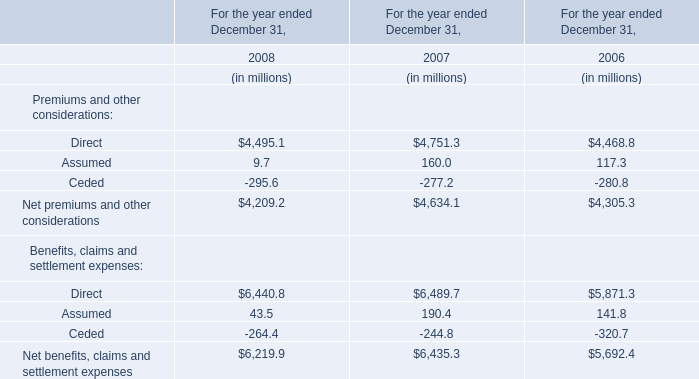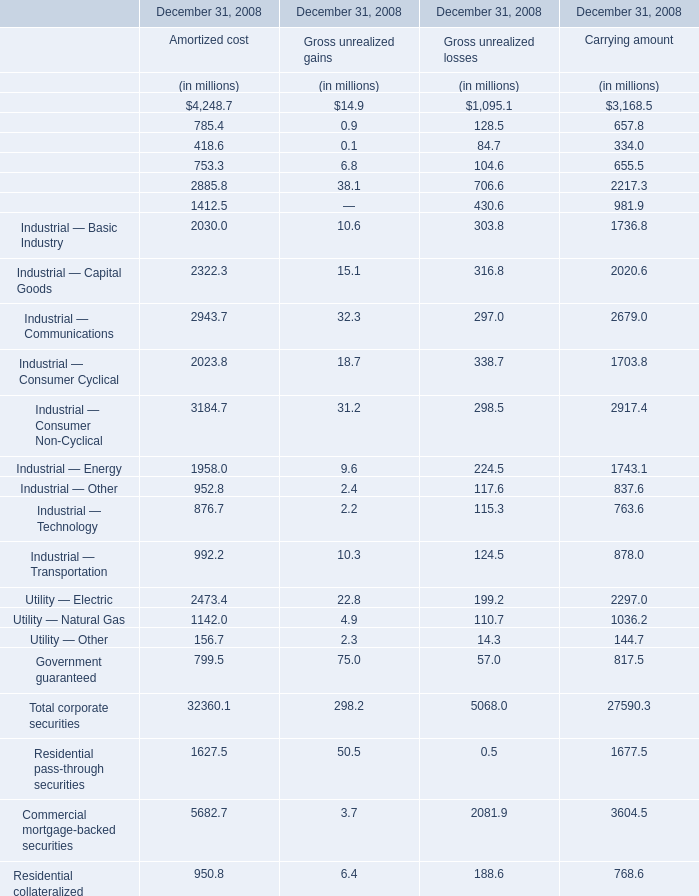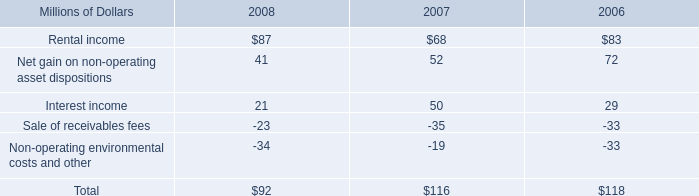what was the average thrift plan contribution from 2006 to 2008 in millions 
Computations: (((14 + 14) + 13) / 3)
Answer: 13.66667. what was the percentage change in rental income from 2006 to 2007? 
Computations: ((68 - 83) / 83)
Answer: -0.18072. 